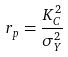Convert formula to latex. <formula><loc_0><loc_0><loc_500><loc_500>r _ { p } = \frac { K _ { C } ^ { 2 } } { \sigma _ { Y } ^ { 2 } }</formula> 